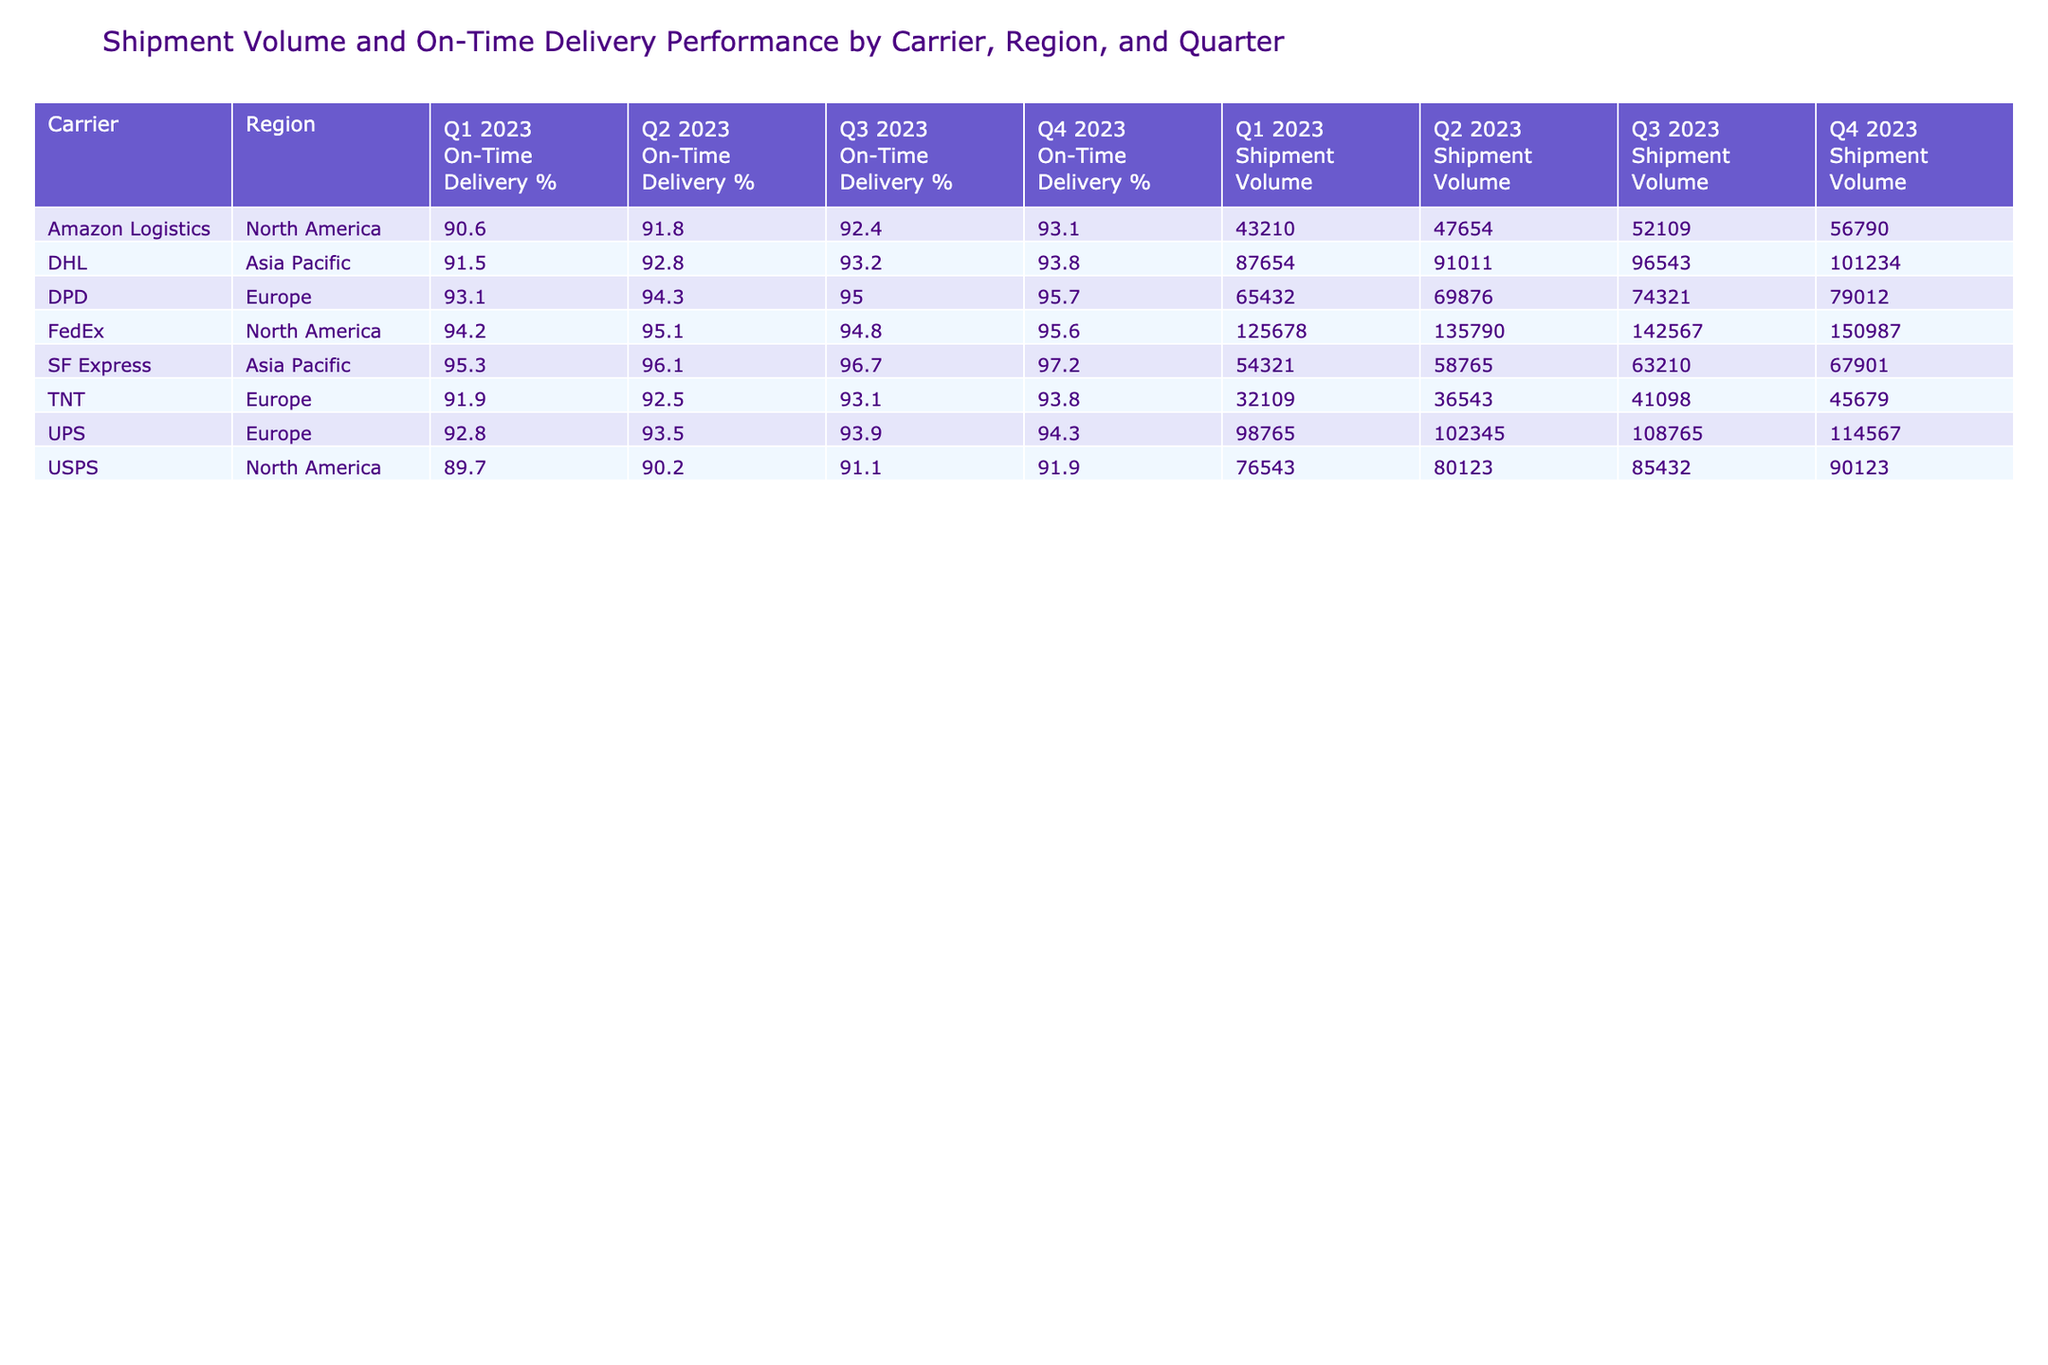What is the total shipment volume for FedEx in North America across all quarters? To find the total shipment volume for FedEx in North America, we look at the shipment volumes listed for each quarter: Q1 2023 (125678), Q2 2023 (135790), Q3 2023 (142567), and Q4 2023 (150987). We sum these values: 125678 + 135790 + 142567 + 150987 = 555022.
Answer: 555022 Which carrier had the highest on-time delivery percentage in Q4 2023? In Q4 2023, we check the on-time delivery percentages for each carrier: FedEx (95.6), UPS (94.3), DHL (93.8), USPS (91.9), DPD (95.7), SF Express (97.2), Amazon Logistics (93.1), and TNT (93.8). The highest percentage is for SF Express at 97.2.
Answer: SF Express What is the average on-time delivery percentage for DPD across all quarters? To compute the average on-time delivery percentage for DPD, we take the values for each quarter: Q1 2023 (93.1), Q2 2023 (94.3), Q3 2023 (95.0), and Q4 2023 (95.7). The sum of these values is 93.1 + 94.3 + 95.0 + 95.7 = 378.1. There are 4 data points, so the average is 378.1 / 4 = 94.525.
Answer: 94.525 Did Amazon Logistics have a higher shipment volume in Q4 2023 compared to Q3 2023? We compare the shipment volumes for Amazon Logistics in both quarters: Q4 2023 (56790) and Q3 2023 (52109). Since 56790 is greater than 52109, the answer is yes.
Answer: Yes Which region had the lowest average on-time delivery percentage across all carriers for Q2 2023? In Q2 2023, we collect the on-time delivery percentages for each carrier by region: North America (94.8, 91.8), Europe (93.5, 94.3), and Asia Pacific (92.8, 96.1). We calculate their averages: North America = (94.8 + 91.8) / 2 = 93.3, Europe = (93.5 + 94.3) / 2 = 93.9, and Asia Pacific = (92.8 + 96.1) / 2 = 94.45. The lowest average is for North America with 93.3.
Answer: North America What was the total shipment volume for UPS across all quarters? We sum the shipment volumes for UPS across each quarter: Q1 2023 (98765), Q2 2023 (102345), Q3 2023 (108765), and Q4 2023 (114567). The total is 98765 + 102345 + 108765 + 114567 = 414442.
Answer: 414442 Is the shipment volume for USPS in Q3 2023 higher than in Q1 2023? We compare the shipment volumes for USPS in the two quarters: Q3 2023 (85432) and Q1 2023 (76543). Since 85432 is greater than 76543, the answer is yes.
Answer: Yes Which carrier had the lowest shipment volume in Q1 2023? In Q1 2023, the shipment volumes for all carriers are: FedEx (125678), UPS (98765), DHL (87654), USPS (76543), DPD (65432), SF Express (54321), Amazon Logistics (43210), and TNT (32109). The lowest value is for TNT at 32109.
Answer: TNT What is the difference in on-time delivery percentage for SF Express between Q1 2023 and Q2 2023? For SF Express, the on-time delivery percentages are Q1 2023 (95.3) and Q2 2023 (96.1). We calculate the difference: 96.1 - 95.3 = 0.8.
Answer: 0.8 